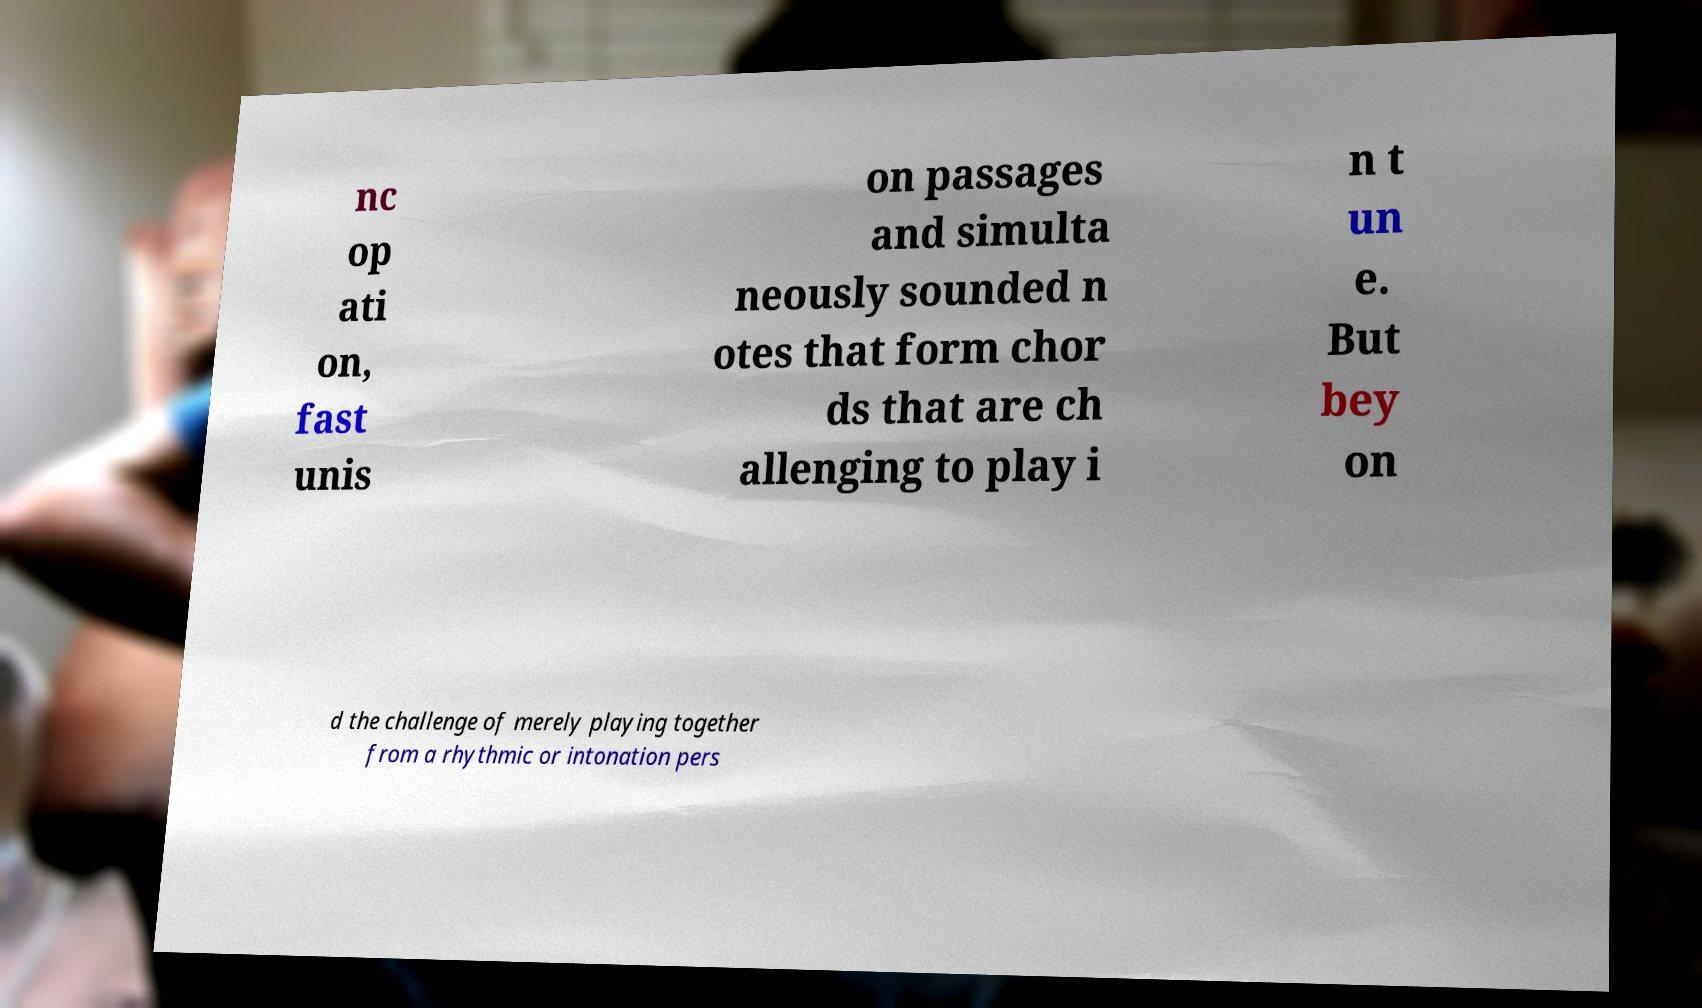Please identify and transcribe the text found in this image. nc op ati on, fast unis on passages and simulta neously sounded n otes that form chor ds that are ch allenging to play i n t un e. But bey on d the challenge of merely playing together from a rhythmic or intonation pers 